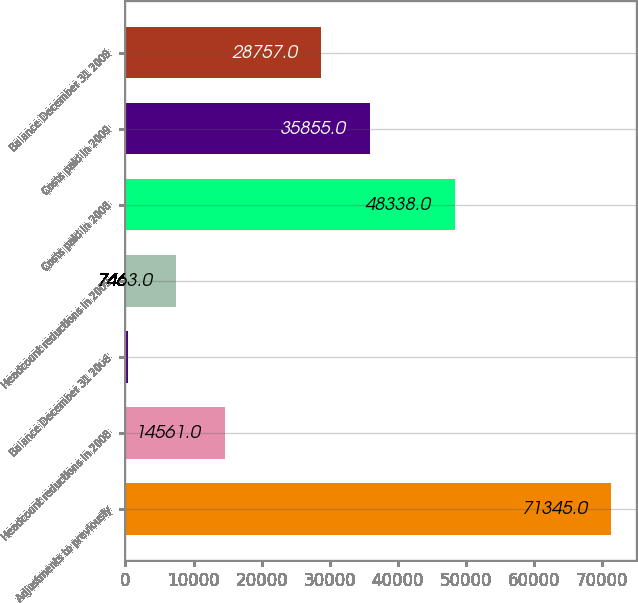<chart> <loc_0><loc_0><loc_500><loc_500><bar_chart><fcel>Adjustments to previously<fcel>Headcount reductions in 2008<fcel>Balance December 31 2008<fcel>Headcount reductions in 2009<fcel>Costs paid in 2008<fcel>Costs paid in 2009<fcel>Balance December 31 2009<nl><fcel>71345<fcel>14561<fcel>365<fcel>7463<fcel>48338<fcel>35855<fcel>28757<nl></chart> 